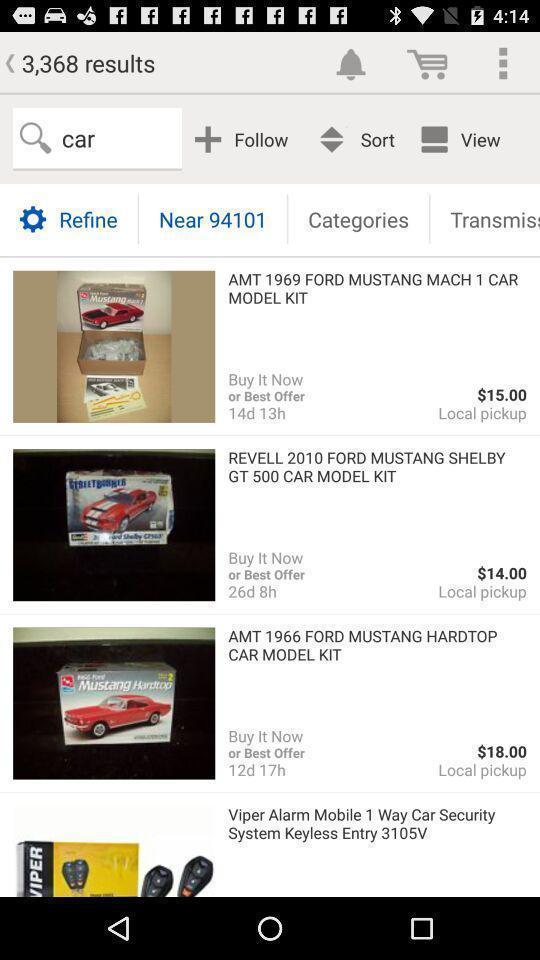Describe the visual elements of this screenshot. Various search results page displayed of a groceries shopping app. 